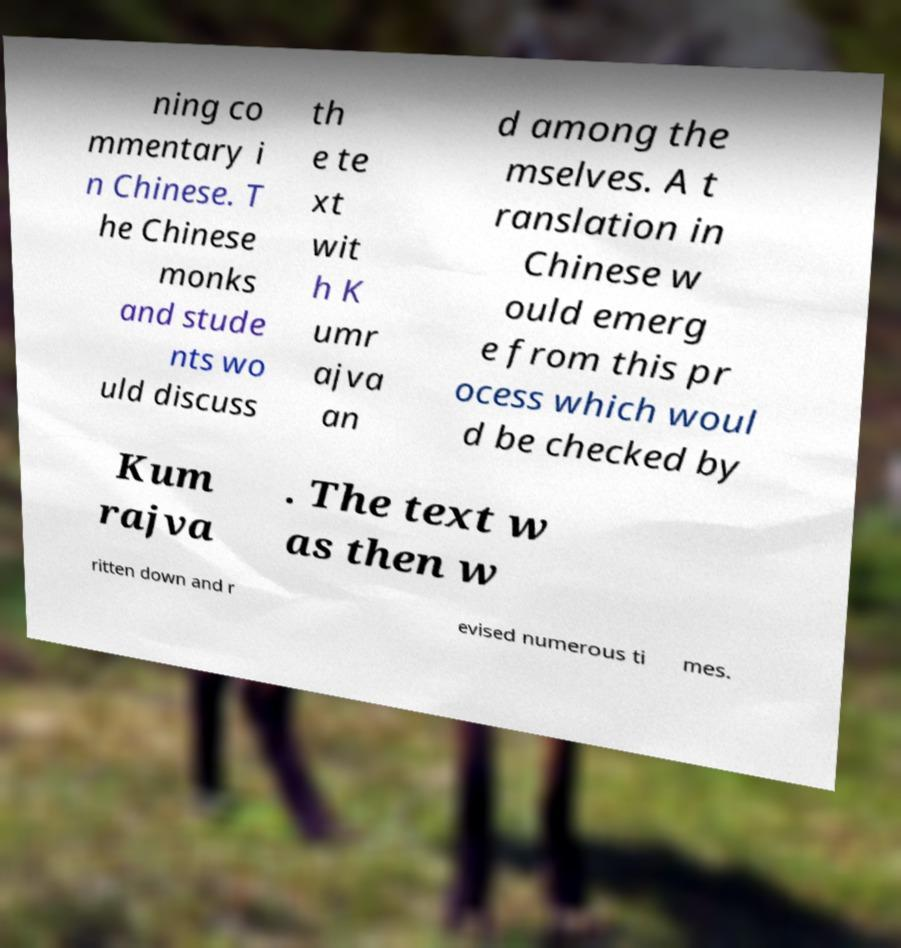Can you read and provide the text displayed in the image?This photo seems to have some interesting text. Can you extract and type it out for me? ning co mmentary i n Chinese. T he Chinese monks and stude nts wo uld discuss th e te xt wit h K umr ajva an d among the mselves. A t ranslation in Chinese w ould emerg e from this pr ocess which woul d be checked by Kum rajva . The text w as then w ritten down and r evised numerous ti mes. 